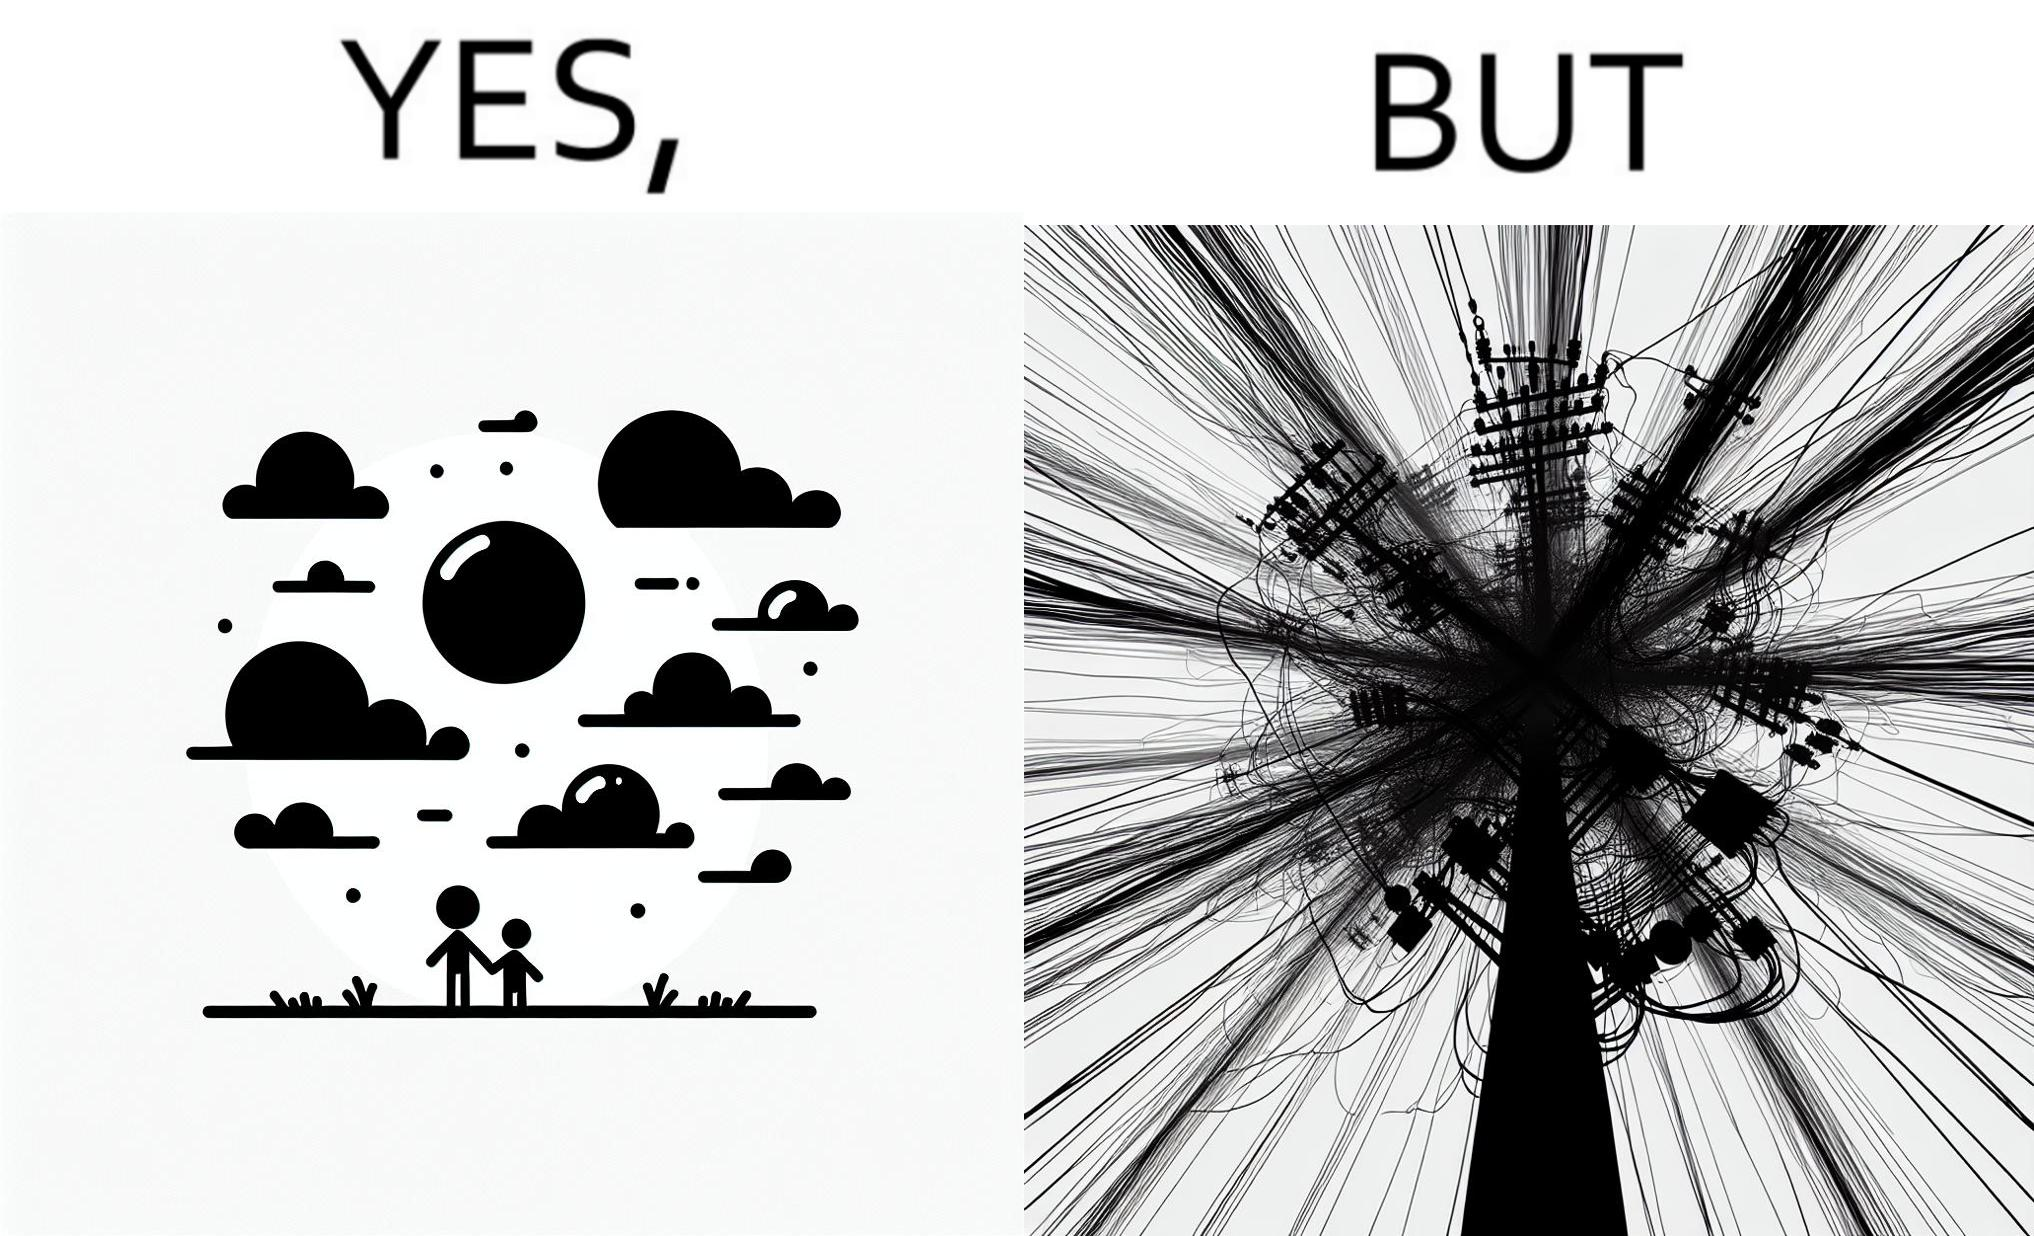What does this image depict? The image is ironic, because in the first image clear sky is visible but in the second image the same view is getting blocked due to the electricity pole 